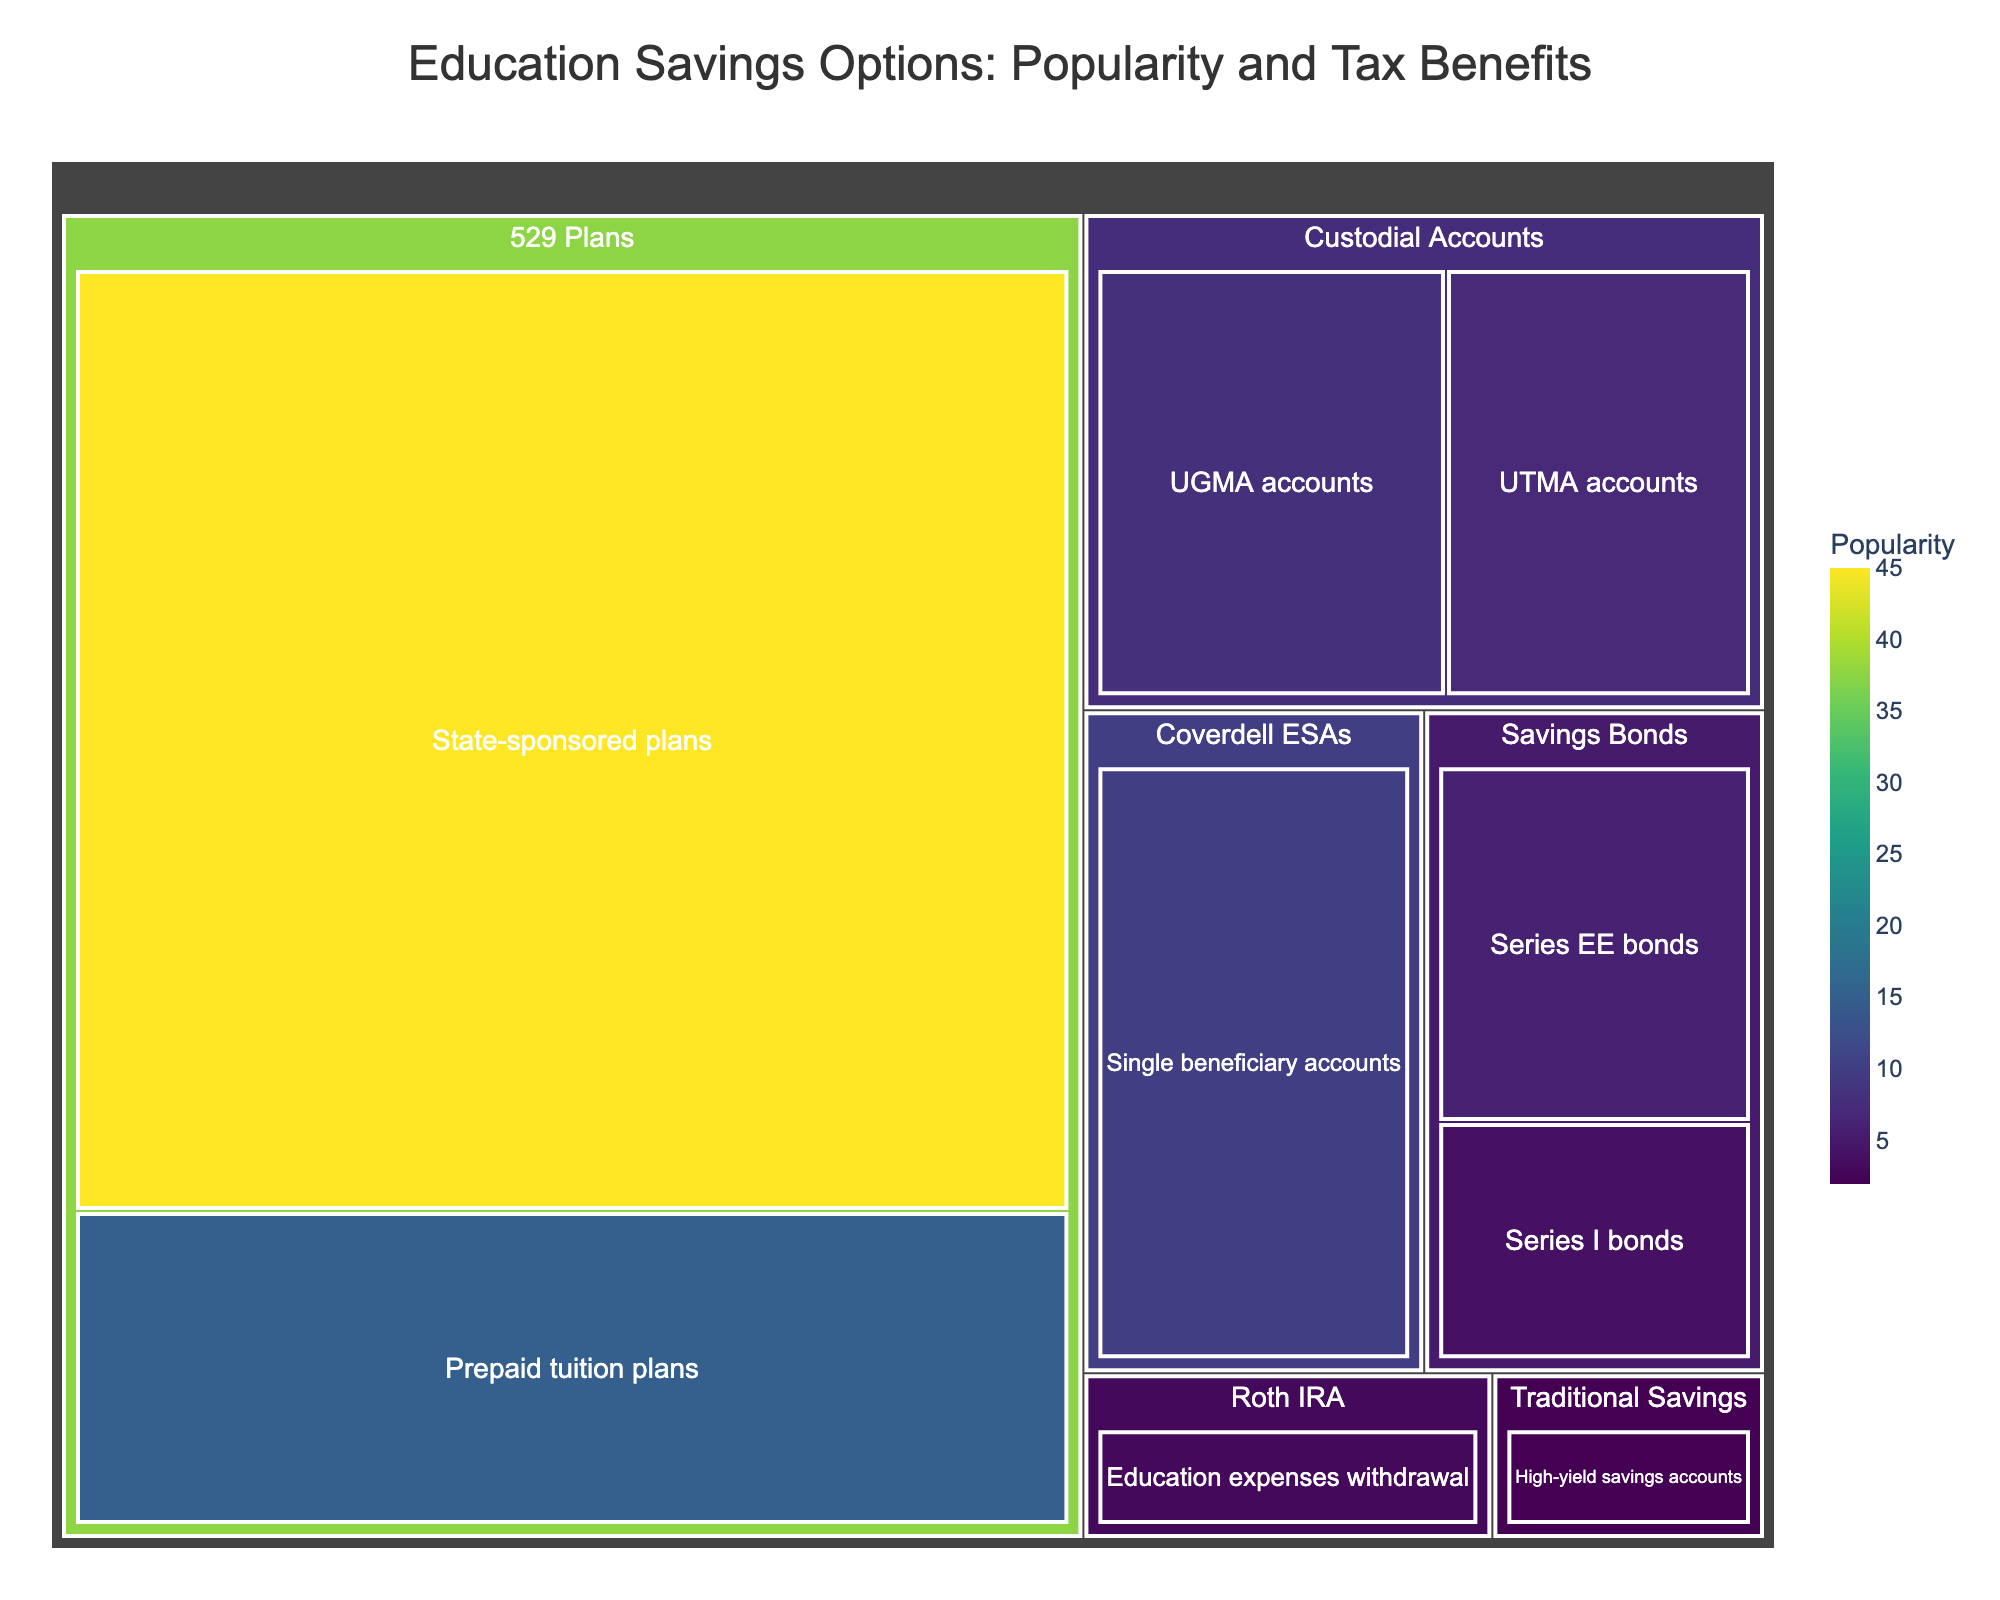What's the title of the treemap? The title of the treemap is usually displayed at the top. In this case, the title is "Education Savings Options: Popularity and Tax Benefits".
Answer: Education Savings Options: Popularity and Tax Benefits How many subcategories are there in the "529 Plans" category? To find this, look for the number of subcategories under "529 Plans". There are "State-sponsored plans" and "Prepaid tuition plans".
Answer: 2 Which savings option category has the least popularity based on the treemap? By observing the size of the tiles representing each category, the smallest one is "Traditional Savings: High-yield savings accounts" with a value of 2.
Answer: Traditional Savings What is the combined popularity value of "Custodial Accounts"? Add the values of the "UGMA accounts" and "UTMA accounts" subcategories in "Custodial Accounts": 8 + 7 = 15.
Answer: 15 Which subcategory in the "Savings Bonds" category is more popular? Compare the values of "Series EE bonds" (6) and "Series I bonds" (4). "Series EE bonds" has a higher value.
Answer: Series EE bonds How does the popularity of "Coverdell ESAs" compare to "Roth IRA: Education expenses withdrawal"? The value for "Coverdell ESAs" is 10 while "Roth IRA: Education expenses withdrawal" is 3. The former is more popular.
Answer: Coverdell ESAs is more popular What is the average popularity value of all categories in the treemap? Sum all values from the data set and divide by the number of subcategories. (45+15+10+8+7+6+4+3+2)/9 = 11
Answer: 11 Which education savings option category is the most popular? The largest tile by value represents "529 Plans" with a combined value of 45 + 15 = 60.
Answer: 529 Plans What is the difference in popularity between "Series EE bonds" and "Series I bonds"? Subtract the value of "Series I bonds" from "Series EE bonds": 6 - 4 = 2.
Answer: 2 How many categories have subcategories with non-zero popularity values? All categories listed in the data set have non-zero values for their subcategories: 529 Plans, Coverdell ESAs, Custodial Accounts, Savings Bonds, Roth IRA, Traditional Savings. There are 6 categories.
Answer: 6 